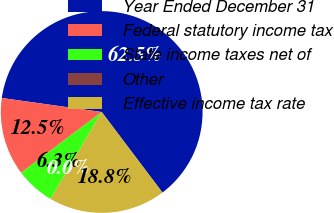Convert chart. <chart><loc_0><loc_0><loc_500><loc_500><pie_chart><fcel>Year Ended December 31<fcel>Federal statutory income tax<fcel>State income taxes net of<fcel>Other<fcel>Effective income tax rate<nl><fcel>62.49%<fcel>12.5%<fcel>6.25%<fcel>0.0%<fcel>18.75%<nl></chart> 